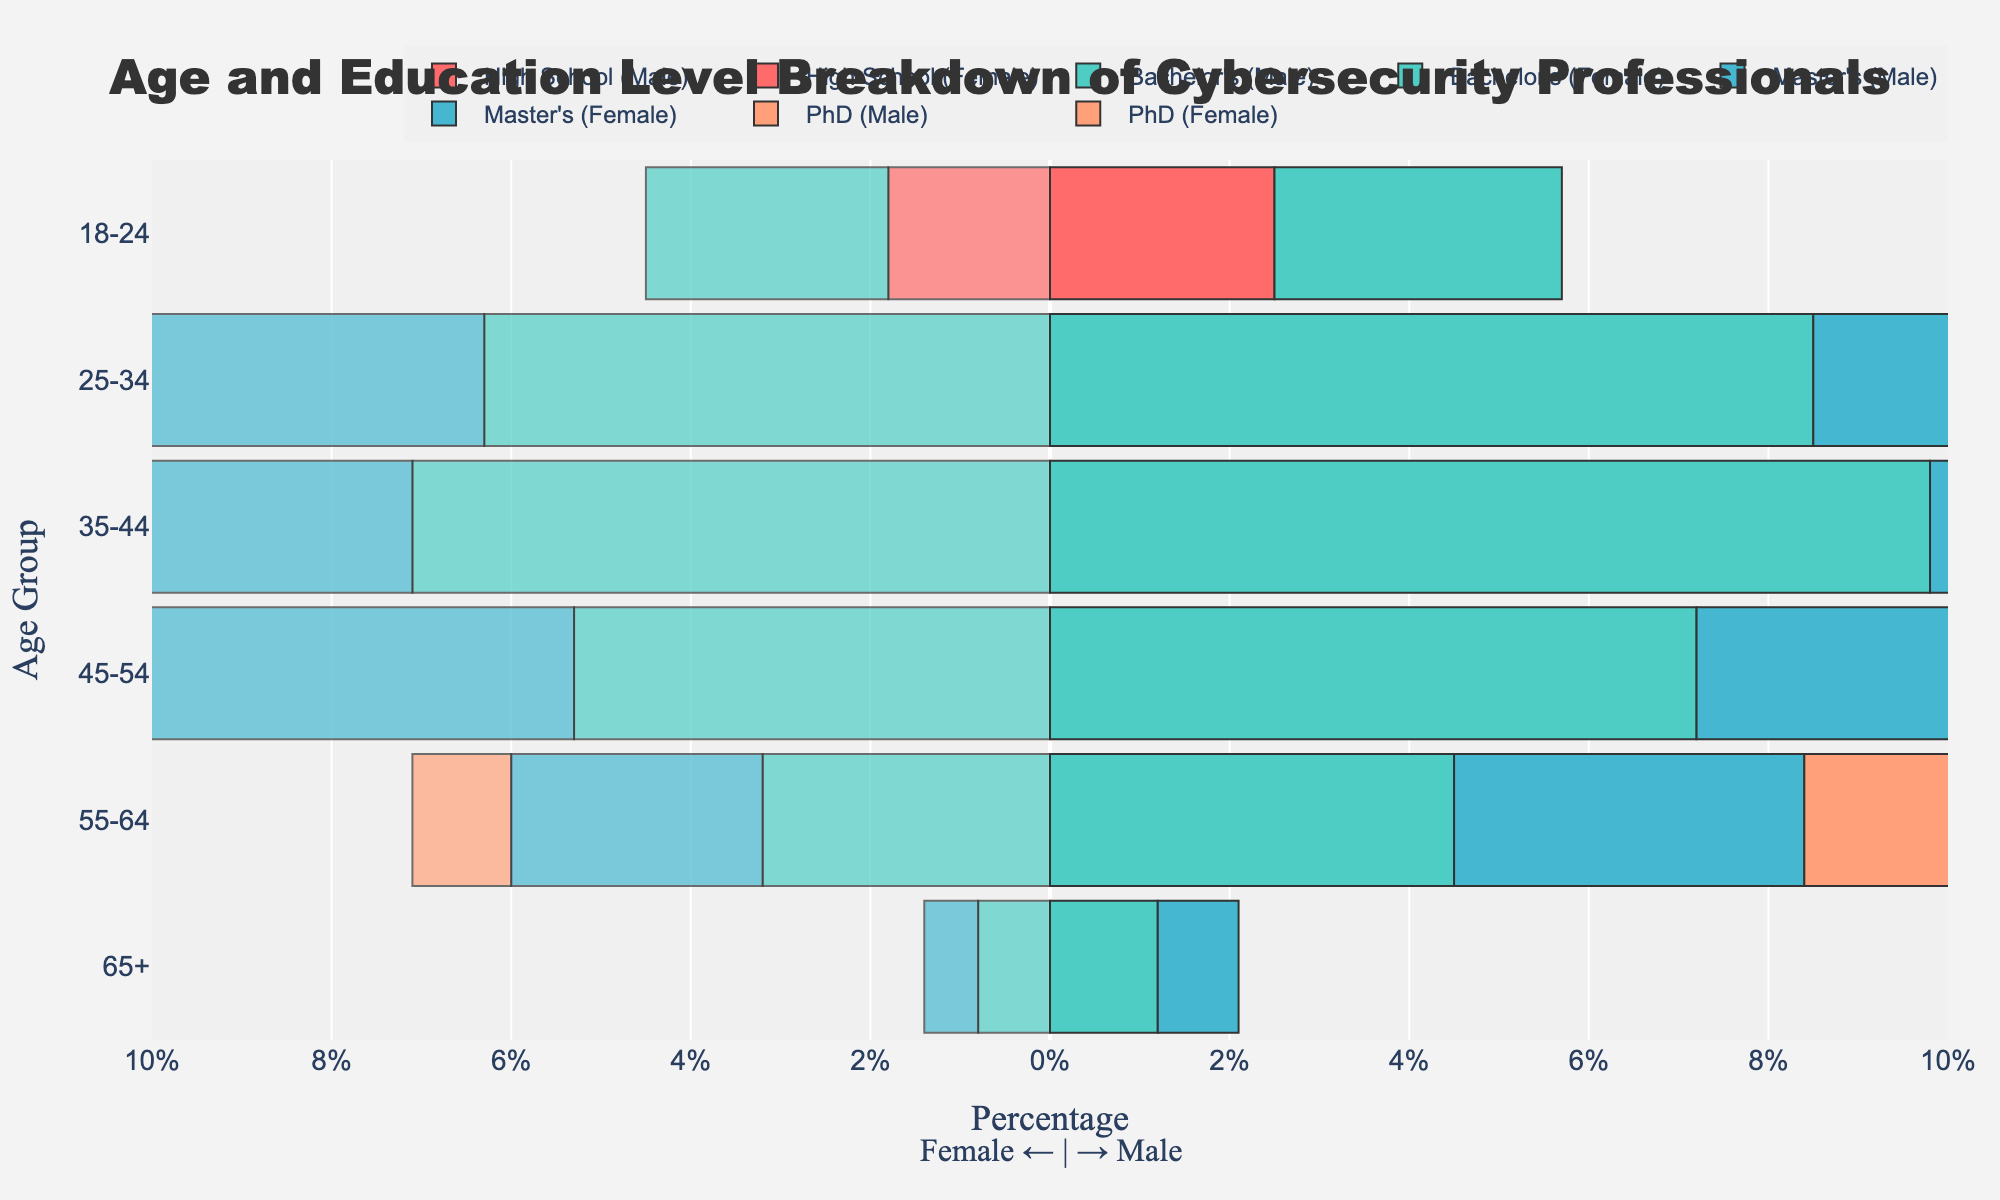how many males are in the 35-44 age group with a bachelor's degree? Look at the bar representing males with a bachelor's degree in the 35-44 age group and sum up the values.
Answer: 9.8% which age group has the highest percentage of females with a master's degree? Identify the highest value among the female bars labeled "Master's" for each age group.
Answer: 35-44 what is the total percentage of cybersecurity professionals aged 18-24 with high school education? Add the percentages of males and females with high school education in the 18-24 age group. 2.5% + 1.8% = 4.3%
Answer: 4.3% compare the percentage of males and females with a PhD in the 45-54 age group. which is higher and by how much? Look at the bars representing males and females with a PhD in the 45-54 age group, and calculate the difference between them. 2.8% - 1.9% = 0.9%
Answer: Male by 0.9% how do the percentages of males and females aged 25-34 with a bachelor's degree compare? Compare the values of the male and female bars labeled "Bachelor's" in the 25-34 age group. 8.5% (male) vs 6.3% (female)
Answer: Males have a higher percentage which education level has the smallest gender gap in the 55-64 age group? Calculate the differences between male and female percentages for each education level in the 55-64 age group and find the smallest difference. High School: 0%, Bachelor's: 1.3%, Master's: 1.1%, PhD: 0.6%
Answer: PhD what is the percentage of females in the 35-44 age group with a PhD? Look at the specific bar representing females with a PhD in the 35-44 age group.
Answer: 1.4% are there more males or females aged 65+ with a bachelor's degree? Compare the lengths of the bars for males and females holding a bachelor's degree in the 65+ age group.
Answer: More males 